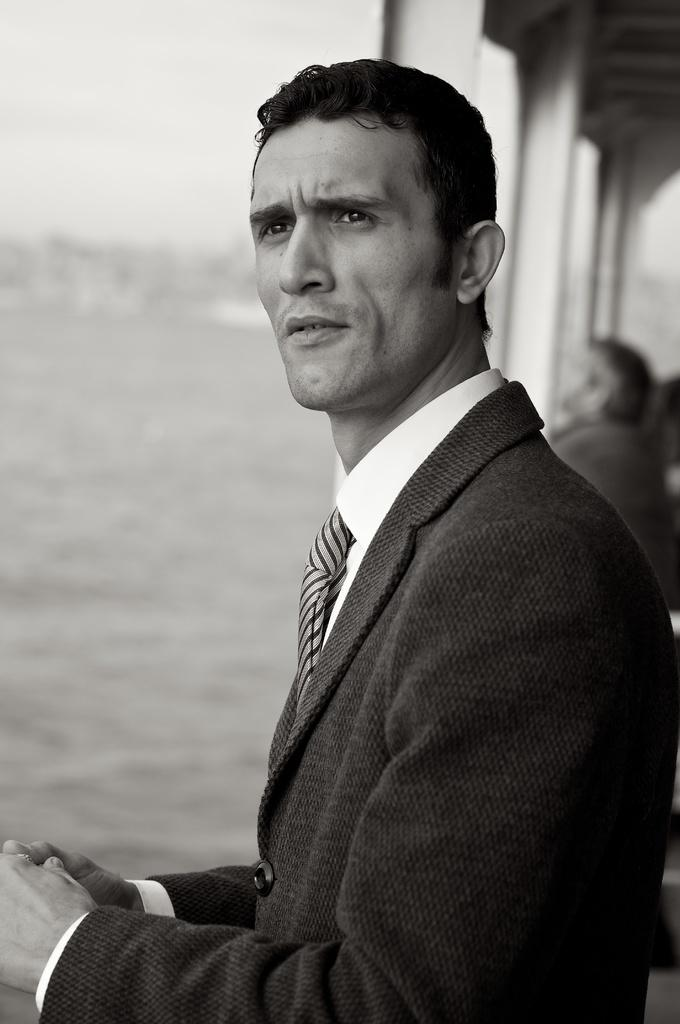What is the main subject in the foreground of the image? There is a person in the foreground of the image. Can you describe the scene in the background? There is another person and poles visible in the background of the image. What natural feature can be seen in the image? There is a river in the image. What type of horse is being ridden by the person in the background? There is no horse present in the image; the person in the background is standing near poles. 